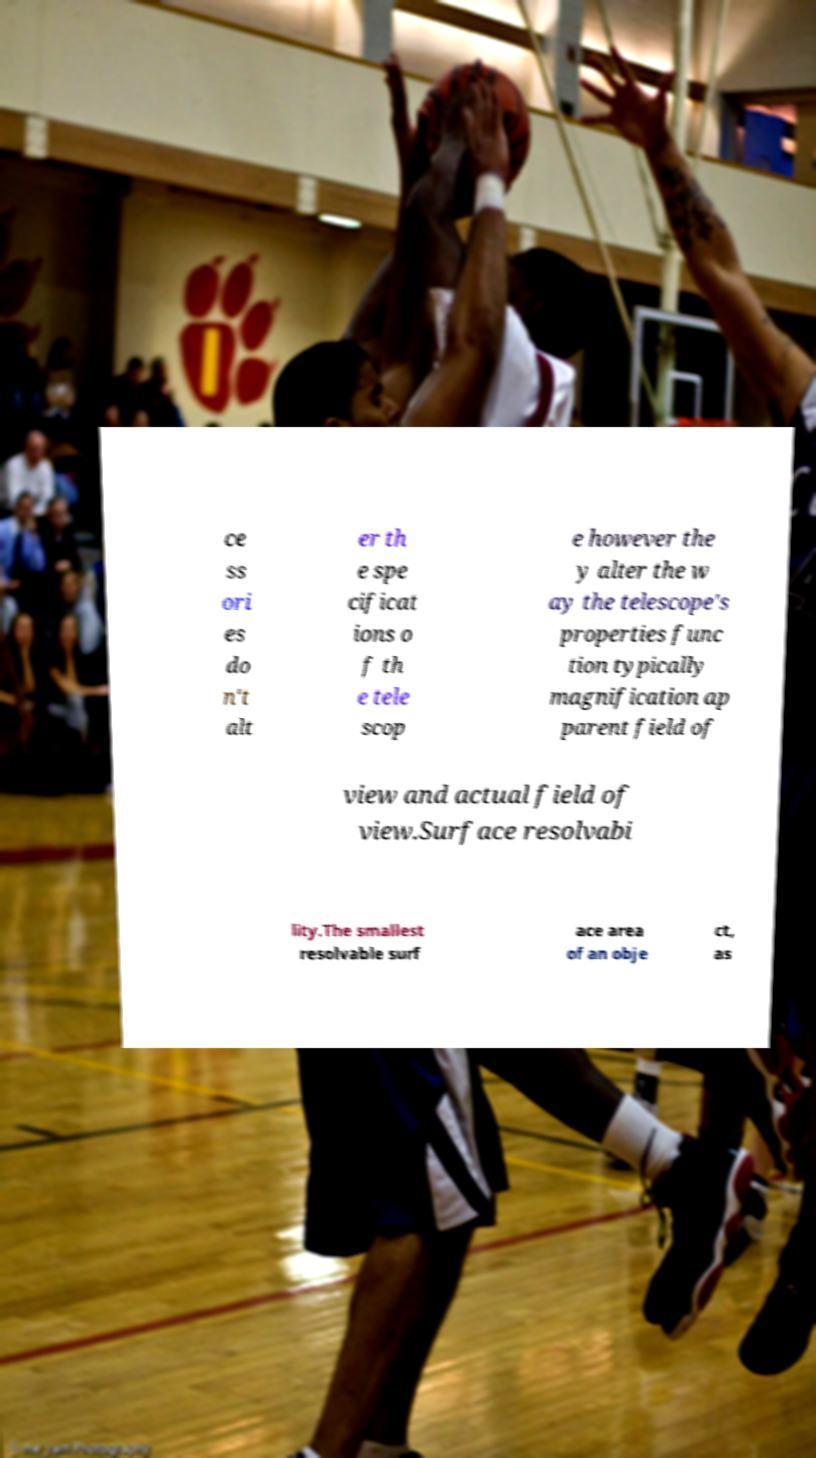For documentation purposes, I need the text within this image transcribed. Could you provide that? ce ss ori es do n't alt er th e spe cificat ions o f th e tele scop e however the y alter the w ay the telescope's properties func tion typically magnification ap parent field of view and actual field of view.Surface resolvabi lity.The smallest resolvable surf ace area of an obje ct, as 